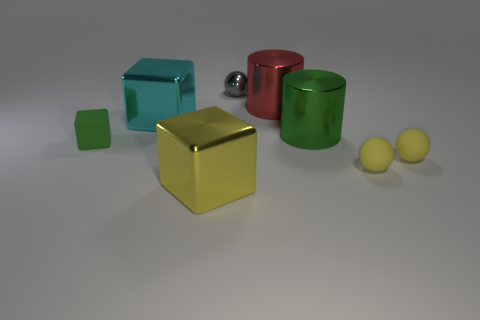Add 2 large green cylinders. How many objects exist? 10 Subtract all balls. How many objects are left? 5 Add 7 tiny cyan blocks. How many tiny cyan blocks exist? 7 Subtract 0 brown cylinders. How many objects are left? 8 Subtract all green metal cylinders. Subtract all tiny blocks. How many objects are left? 6 Add 4 big metal cylinders. How many big metal cylinders are left? 6 